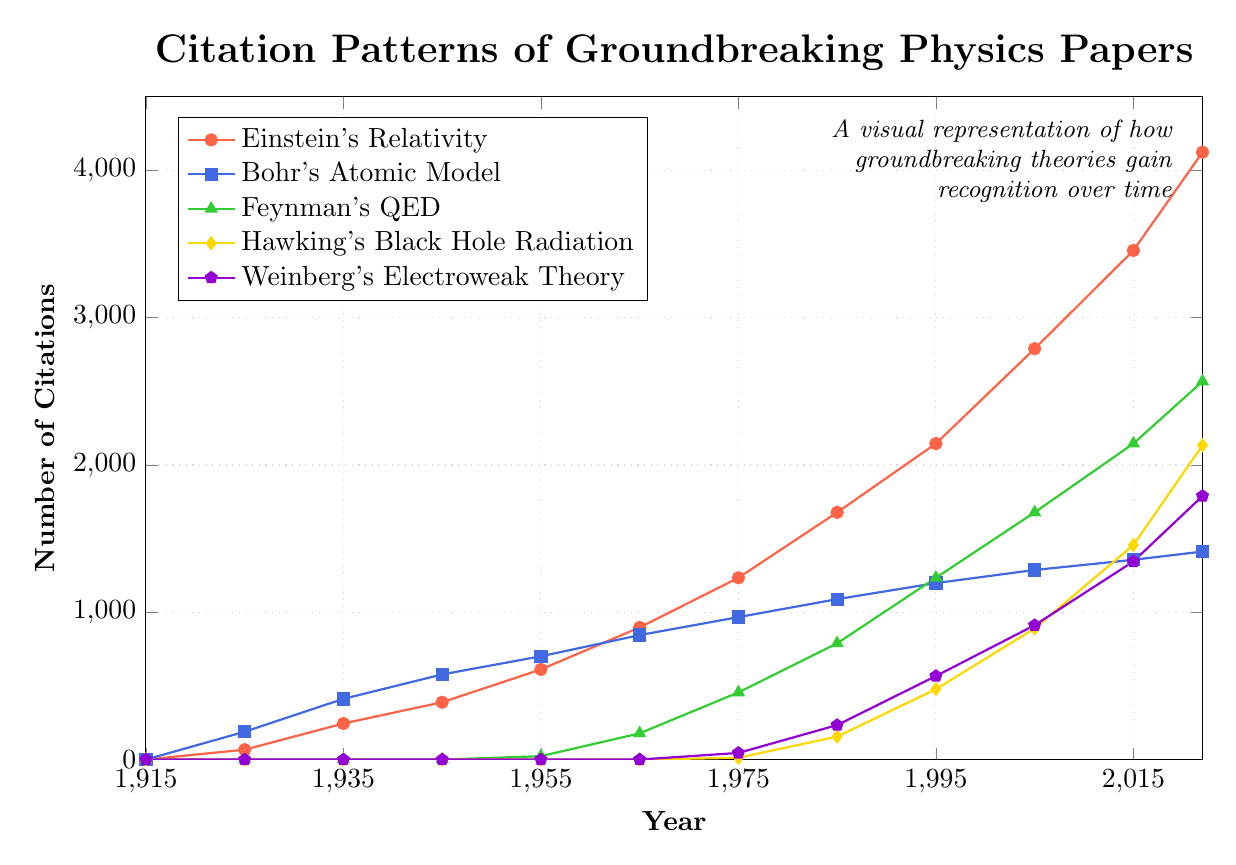What's the trend for Hawking's Black Hole Radiation from 1975 to 2022? The number of citations for Hawking's Black Hole Radiation starts at 12 in 1975 and increases over time, reaching 2134 in 2022. The trend shows a consistent rise.
Answer: Increasing trend Which paper has the highest citations in 2022? Looking at the highest point for 2022, it's clear that Einstein's Relativity has the highest citations with 4123.
Answer: Einstein's Relativity Between which pairs of years did Bohr's Atomic Model experience the greatest increase in citations? To find the greatest increase, subtract the number of citations in consecutive years and compare the differences: (1935-1925=223), (1945-1935=166), (1955-1945=123), etc. The largest increase is between 1925 and 1935, going from 189 to 412.
Answer: 1925 to 1935 What is the overall pattern observed for Weinberg's Electroweak Theory citations? Citations for Weinberg's Electroweak Theory start in 1975 and show a consistent increase, reaching 1789 by 2022. There’s a noticeable upward trend over the entire period.
Answer: Consistent increase Which paper had fewer citations in 1975, Feynman's QED or Hawking's Black Hole Radiation? Feynman's QED had 456 citations, while Hawking's Black Hole Radiation had 12 citations in 1975.
Answer: Hawking's Black Hole Radiation How many total citations are there for Einstein's Relativity in the available years? Summing up Einstein's Relativity citations from each year: 0+67+245+389+612+897+1234+1678+2145+2789+3456+4123 = 15635
Answer: 15635 In what year did Bohr's Atomic Model first exceed 500 citations? Looking at the values, Bohr's Atomic Model first exceeded 500 citations in 1945 with 578 citations.
Answer: 1945 What color represents Feynman's QED in the chart? Feynman’s QED is indicated by the green line with triangle markers.
Answer: Green Compare the citation patterns of Hawking's Black Hole Radiation and Weinberg's Electroweak Theory. What can you infer? Both papers show citations starting around 1975 and increasing over time. However, Hawking's Black Hole Radiation consistently has more citations than Weinberg's Electroweak Theory, especially after 2005.
Answer: Hawking's Black Hole Radiation has more During which period did Einstein's Relativity experience the most significant growth in citations? By comparing the differences over each period: (67-0=67), (245-67=178), (389-245=144), (612-389=223), (897-612=285), (1234-897=337), etc., the largest increase is from 1925 to 1935, with an increase of 178.
Answer: 1925 to 1935 